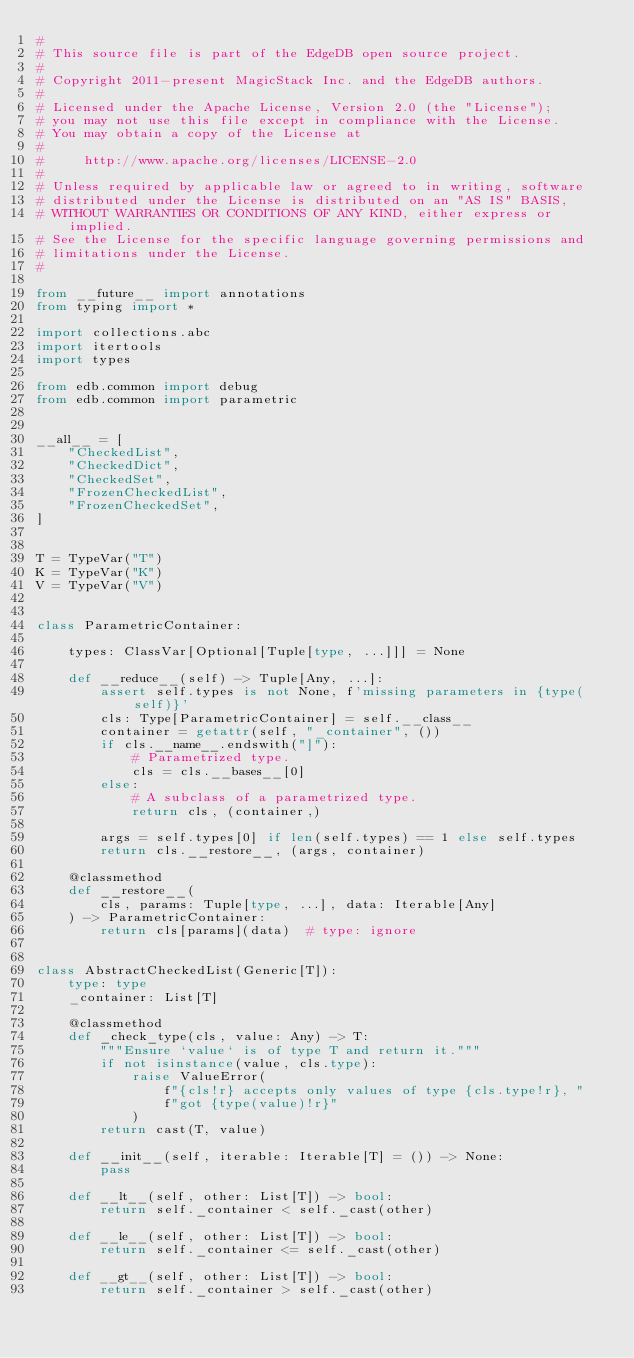Convert code to text. <code><loc_0><loc_0><loc_500><loc_500><_Python_>#
# This source file is part of the EdgeDB open source project.
#
# Copyright 2011-present MagicStack Inc. and the EdgeDB authors.
#
# Licensed under the Apache License, Version 2.0 (the "License");
# you may not use this file except in compliance with the License.
# You may obtain a copy of the License at
#
#     http://www.apache.org/licenses/LICENSE-2.0
#
# Unless required by applicable law or agreed to in writing, software
# distributed under the License is distributed on an "AS IS" BASIS,
# WITHOUT WARRANTIES OR CONDITIONS OF ANY KIND, either express or implied.
# See the License for the specific language governing permissions and
# limitations under the License.
#

from __future__ import annotations
from typing import *

import collections.abc
import itertools
import types

from edb.common import debug
from edb.common import parametric


__all__ = [
    "CheckedList",
    "CheckedDict",
    "CheckedSet",
    "FrozenCheckedList",
    "FrozenCheckedSet",
]


T = TypeVar("T")
K = TypeVar("K")
V = TypeVar("V")


class ParametricContainer:

    types: ClassVar[Optional[Tuple[type, ...]]] = None

    def __reduce__(self) -> Tuple[Any, ...]:
        assert self.types is not None, f'missing parameters in {type(self)}'
        cls: Type[ParametricContainer] = self.__class__
        container = getattr(self, "_container", ())
        if cls.__name__.endswith("]"):
            # Parametrized type.
            cls = cls.__bases__[0]
        else:
            # A subclass of a parametrized type.
            return cls, (container,)

        args = self.types[0] if len(self.types) == 1 else self.types
        return cls.__restore__, (args, container)

    @classmethod
    def __restore__(
        cls, params: Tuple[type, ...], data: Iterable[Any]
    ) -> ParametricContainer:
        return cls[params](data)  # type: ignore


class AbstractCheckedList(Generic[T]):
    type: type
    _container: List[T]

    @classmethod
    def _check_type(cls, value: Any) -> T:
        """Ensure `value` is of type T and return it."""
        if not isinstance(value, cls.type):
            raise ValueError(
                f"{cls!r} accepts only values of type {cls.type!r}, "
                f"got {type(value)!r}"
            )
        return cast(T, value)

    def __init__(self, iterable: Iterable[T] = ()) -> None:
        pass

    def __lt__(self, other: List[T]) -> bool:
        return self._container < self._cast(other)

    def __le__(self, other: List[T]) -> bool:
        return self._container <= self._cast(other)

    def __gt__(self, other: List[T]) -> bool:
        return self._container > self._cast(other)
</code> 